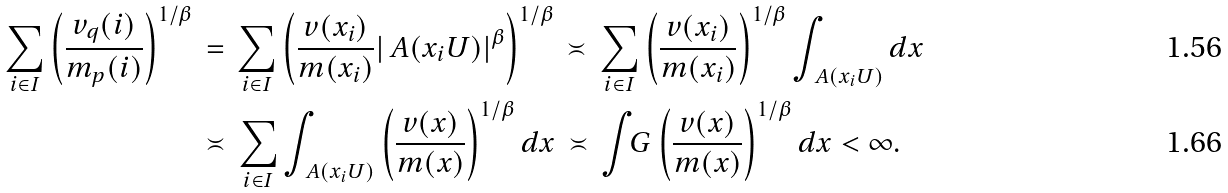Convert formula to latex. <formula><loc_0><loc_0><loc_500><loc_500>\sum _ { i \in I } \left ( \frac { v _ { q } ( i ) } { m _ { p } ( i ) } \right ) ^ { 1 / \beta } \, & = \, \sum _ { i \in I } \left ( \frac { v ( x _ { i } ) } { m ( x _ { i } ) } | \ A ( x _ { i } U ) | ^ { \beta } \right ) ^ { 1 / \beta } \, \asymp \, \sum _ { i \in I } \left ( \frac { v ( x _ { i } ) } { m ( x _ { i } ) } \right ) ^ { 1 / \beta } \int _ { \ A ( x _ { i } U ) } d x \\ & \asymp \, \sum _ { i \in I } \int _ { \ A ( x _ { i } U ) } \left ( \frac { v ( x ) } { m ( x ) } \right ) ^ { 1 / \beta } d x \, \asymp \, \int _ { \ } G \left ( \frac { v ( x ) } { m ( x ) } \right ) ^ { 1 / \beta } d x < \infty .</formula> 